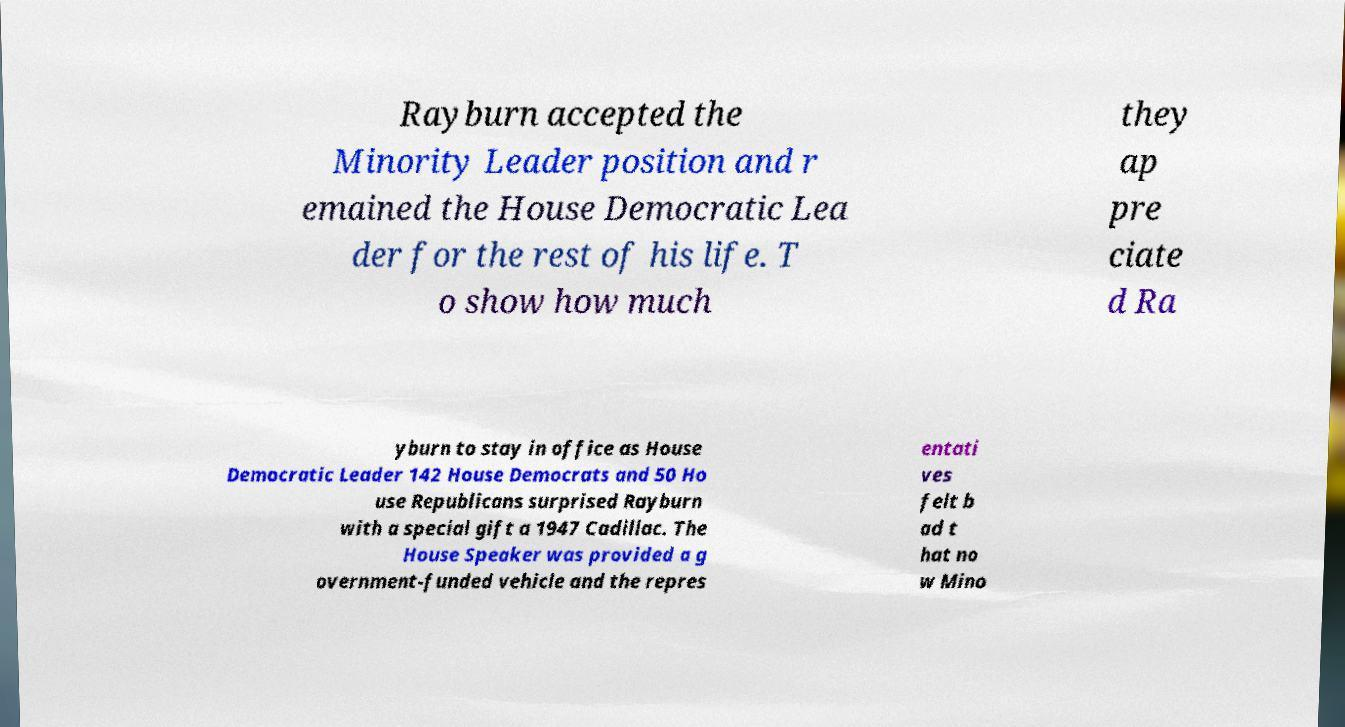Could you assist in decoding the text presented in this image and type it out clearly? Rayburn accepted the Minority Leader position and r emained the House Democratic Lea der for the rest of his life. T o show how much they ap pre ciate d Ra yburn to stay in office as House Democratic Leader 142 House Democrats and 50 Ho use Republicans surprised Rayburn with a special gift a 1947 Cadillac. The House Speaker was provided a g overnment-funded vehicle and the repres entati ves felt b ad t hat no w Mino 